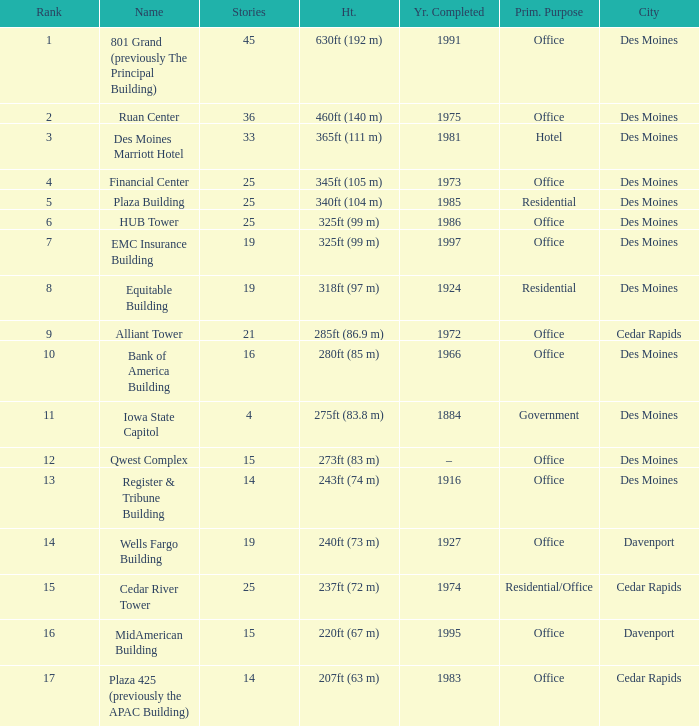What is the total stories that rank number 10? 1.0. 